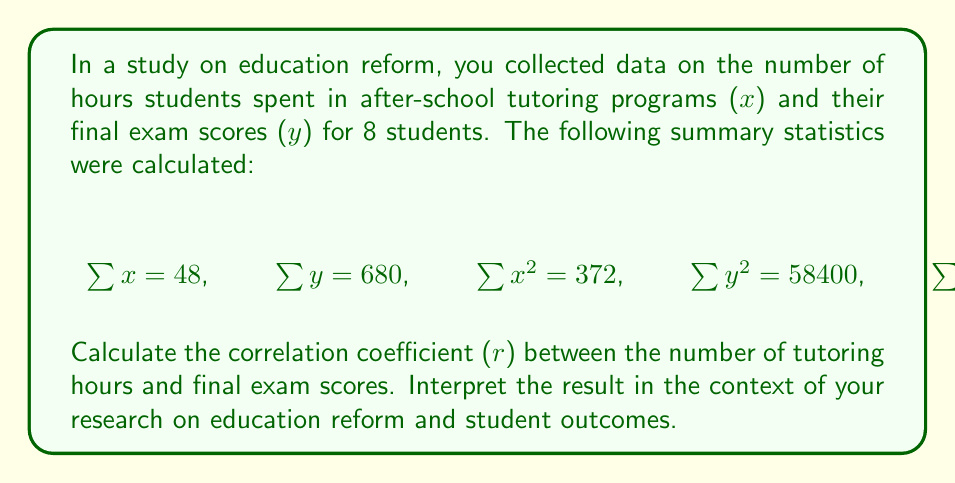Could you help me with this problem? To calculate the correlation coefficient (r), we'll use the formula:

$$ r = \frac{n\sum xy - \sum x \sum y}{\sqrt{[n\sum x^2 - (\sum x)^2][n\sum y^2 - (\sum y)^2]}} $$

Where n is the number of data points (8 in this case).

Step 1: Calculate $n\sum xy - \sum x \sum y$
$$ 8(4140) - 48(680) = 33120 - 32640 = 480 $$

Step 2: Calculate $n\sum x^2 - (\sum x)^2$
$$ 8(372) - 48^2 = 2976 - 2304 = 672 $$

Step 3: Calculate $n\sum y^2 - (\sum y)^2$
$$ 8(58400) - 680^2 = 467200 - 462400 = 4800 $$

Step 4: Multiply the results from steps 2 and 3
$$ 672 * 4800 = 3,225,600 $$

Step 5: Take the square root of step 4
$$ \sqrt{3,225,600} = 1796 $$

Step 6: Divide the result from step 1 by the result from step 5
$$ r = \frac{480}{1796} \approx 0.2673 $$

Interpretation: The correlation coefficient of approximately 0.2673 indicates a weak positive correlation between the number of hours spent in after-school tutoring programs and final exam scores. This suggests that while there is a slight tendency for students who spend more time in tutoring to perform better on final exams, the relationship is not strong. In the context of education reform research, this result implies that after-school tutoring programs may have a small positive impact on student outcomes, but other factors likely play a more significant role in determining exam performance.
Answer: $r \approx 0.2673$, indicating a weak positive correlation 